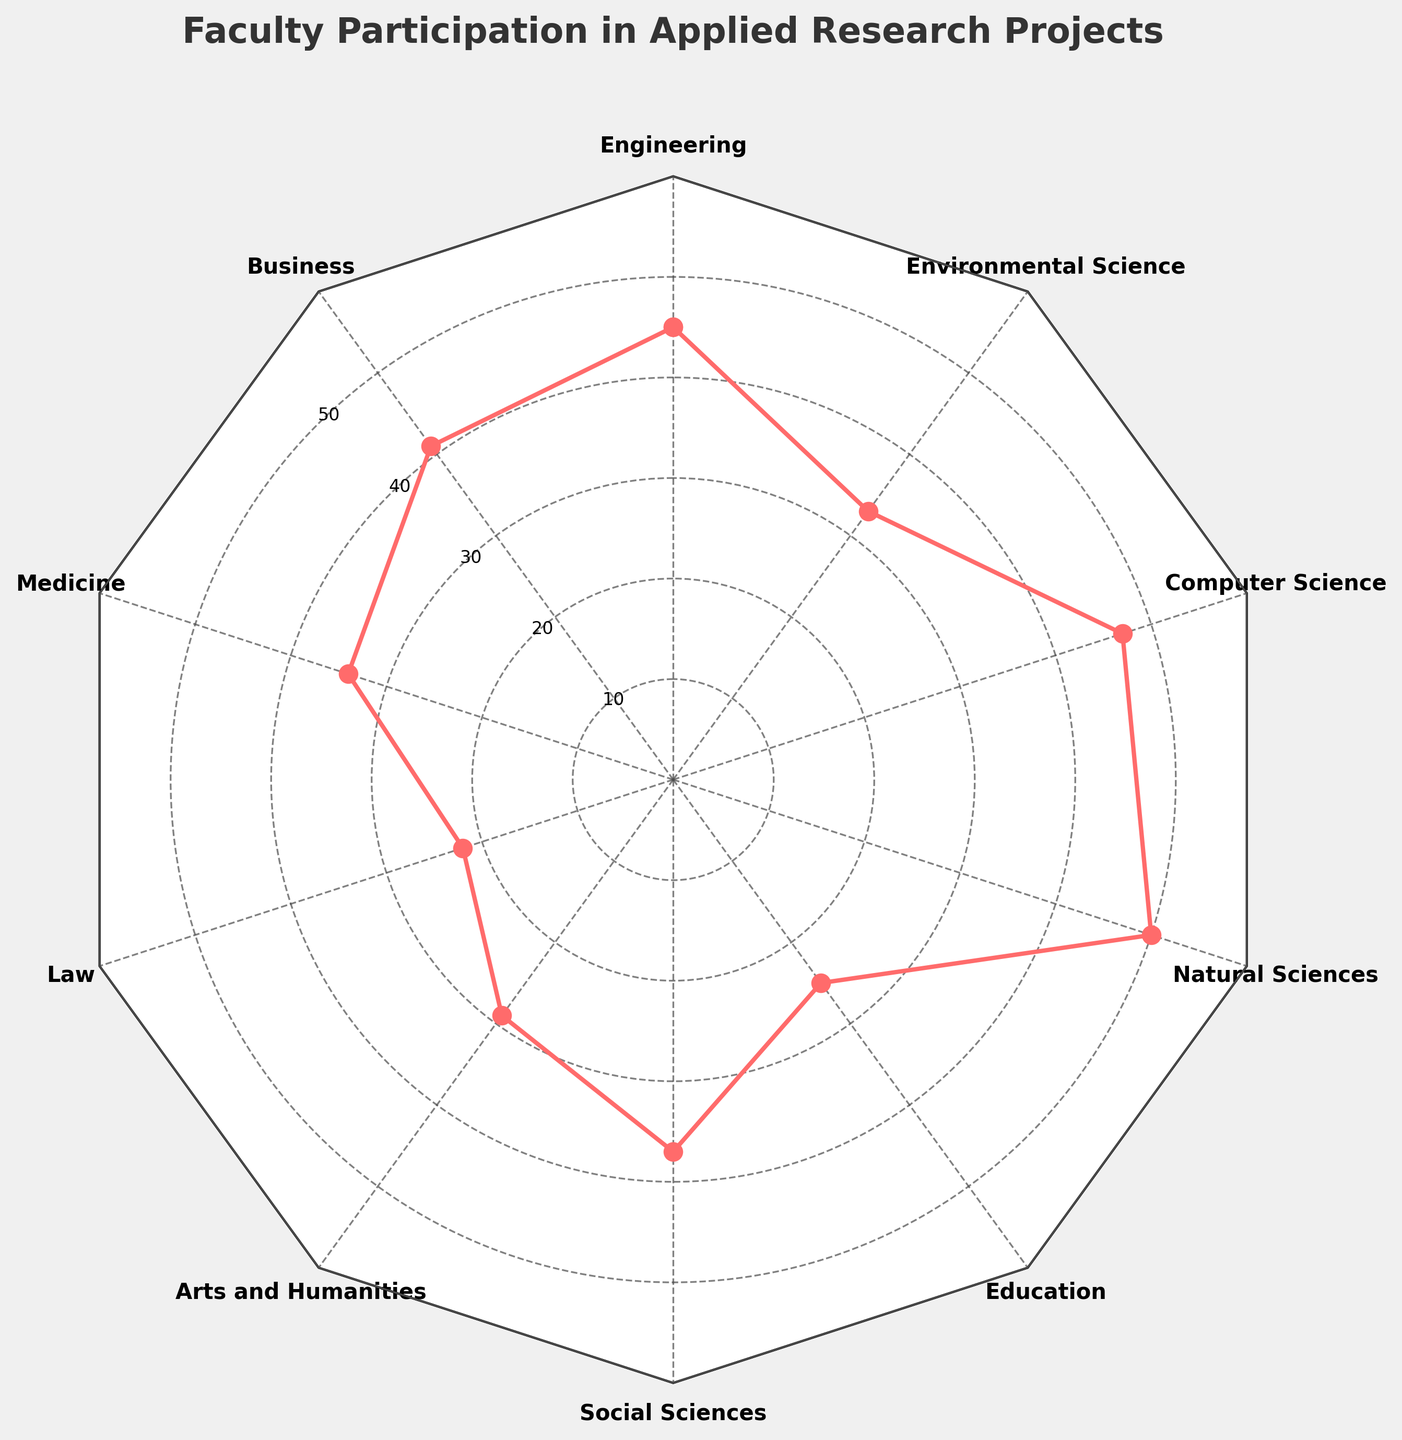What is the title of the radar chart? The title is prominently displayed at the top of the radar chart. It reads "Faculty Participation in Applied Research Projects".
Answer: Faculty Participation in Applied Research Projects Which discipline has the highest number of faculty participants? By examining the radar chart, the segment with the largest value represents the discipline. In this case, the highest value is at "Natural Sciences" with 50 participants.
Answer: Natural Sciences How many faculty participants are there in the Engineering discipline? The radar chart shows the number of participants for each discipline in the corresponding segment. For Engineering, it is 45.
Answer: 45 What is the difference in the number of faculty participants between Computer Science and Medicine? The number of participants in Computer Science is 47, and in Medicine, it is 34. The difference is found by subtracting Medicine's participants from Computer Science's: 47 - 34.
Answer: 13 Which discipline has fewer faculty participants: Arts and Humanities or Education? Comparing the segments for Arts and Humanities and Education, Arts and Humanities has 29 participants while Education has 25.
Answer: Education What is the sum of the faculty participants from Business, Medicine, and Environmental Science disciplines? Adding the participants from these disciplines: Business (41) + Medicine (34) + Environmental Science (33), the total is 41 + 34 + 33.
Answer: 108 Does the Social Sciences discipline have more faculty participants than Law? Comparing the values on the radar chart, Social Sciences has 37 while Law has 22, showing that Social Sciences has more.
Answer: Yes What is the total number of faculty participants across all disciplines? Summing up the participants from all disciplines: 45 (Engineering) + 41 (Business) + 34 (Medicine) + 22 (Law) + 29 (Arts and Humanities) + 37 (Social Sciences) + 25 (Education) + 50 (Natural Sciences) + 47 (Computer Science) + 33 (Environmental Science).
Answer: 363 What is the average number of faculty participants per discipline? First, find the total participants, which is 363. Then, divide this by the number of disciplines, which is 10: 363 / 10.
Answer: 36.3 Which disciplines have more faculty participants than the average number of participants? The average number is 36.3. Disciplines with more participants than this are Engineering (45), Business (41), Social Sciences (37), Natural Sciences (50), and Computer Science (47).
Answer: Engineering, Business, Social Sciences, Natural Sciences, Computer Science 